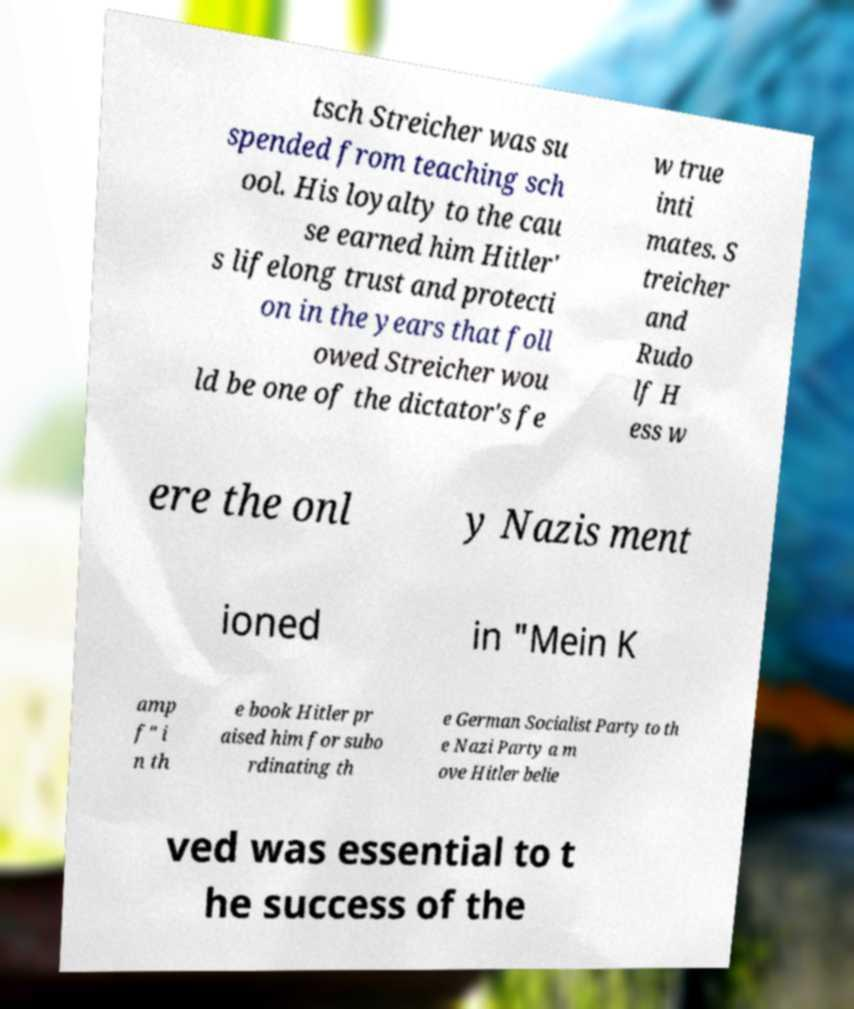I need the written content from this picture converted into text. Can you do that? tsch Streicher was su spended from teaching sch ool. His loyalty to the cau se earned him Hitler' s lifelong trust and protecti on in the years that foll owed Streicher wou ld be one of the dictator's fe w true inti mates. S treicher and Rudo lf H ess w ere the onl y Nazis ment ioned in "Mein K amp f" i n th e book Hitler pr aised him for subo rdinating th e German Socialist Party to th e Nazi Party a m ove Hitler belie ved was essential to t he success of the 